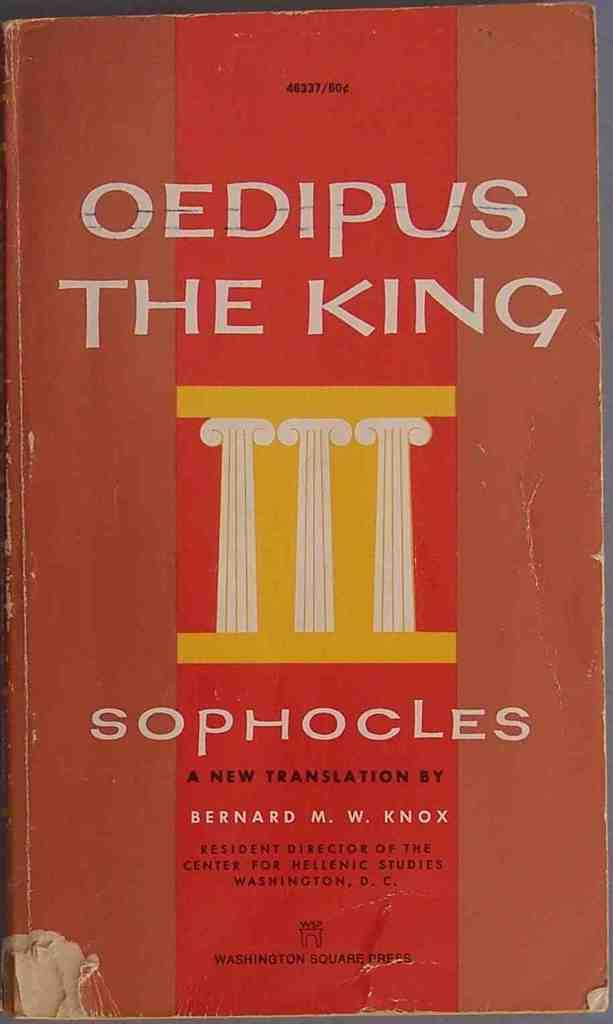<image>
Share a concise interpretation of the image provided. The cover of Oedipus the King, Sophocles a new translation by Bernard M.W. Knox is shown. 